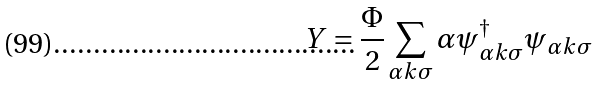Convert formula to latex. <formula><loc_0><loc_0><loc_500><loc_500>Y = \frac { \Phi } { 2 } \sum _ { \alpha k \sigma } \alpha \psi ^ { \dag } _ { \alpha k \sigma } \psi _ { \alpha k \sigma }</formula> 